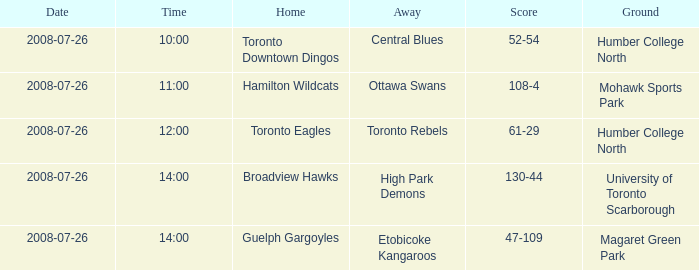At humber college north ground at noon, what was the away situation? Toronto Rebels. Could you parse the entire table? {'header': ['Date', 'Time', 'Home', 'Away', 'Score', 'Ground'], 'rows': [['2008-07-26', '10:00', 'Toronto Downtown Dingos', 'Central Blues', '52-54', 'Humber College North'], ['2008-07-26', '11:00', 'Hamilton Wildcats', 'Ottawa Swans', '108-4', 'Mohawk Sports Park'], ['2008-07-26', '12:00', 'Toronto Eagles', 'Toronto Rebels', '61-29', 'Humber College North'], ['2008-07-26', '14:00', 'Broadview Hawks', 'High Park Demons', '130-44', 'University of Toronto Scarborough'], ['2008-07-26', '14:00', 'Guelph Gargoyles', 'Etobicoke Kangaroos', '47-109', 'Magaret Green Park']]} 